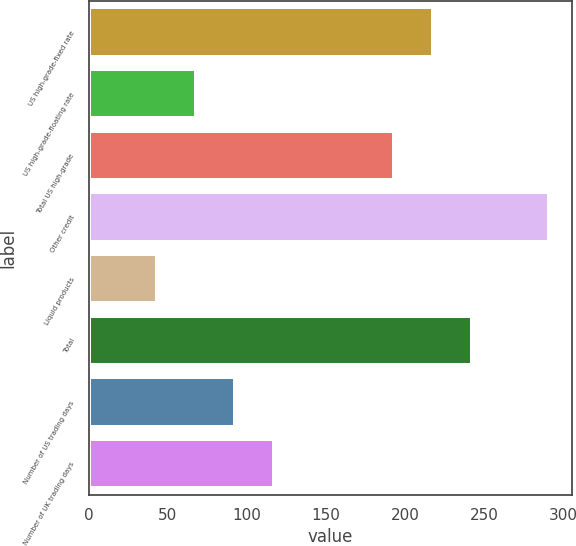<chart> <loc_0><loc_0><loc_500><loc_500><bar_chart><fcel>US high-grade-fixed rate<fcel>US high-grade-floating rate<fcel>Total US high-grade<fcel>Other credit<fcel>Liquid products<fcel>Total<fcel>Number of US trading days<fcel>Number of UK trading days<nl><fcel>217.8<fcel>67.8<fcel>193<fcel>291<fcel>43<fcel>242.6<fcel>92.6<fcel>117.4<nl></chart> 